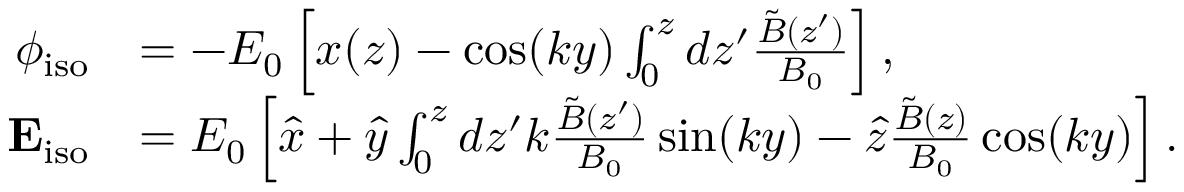Convert formula to latex. <formula><loc_0><loc_0><loc_500><loc_500>\begin{array} { r l } { \phi _ { i s o } } & { = - E _ { 0 } \left [ x ( z ) - \cos ( k y ) \int _ { 0 } ^ { z } d z ^ { \prime } \frac { \tilde { B } ( z ^ { \prime } ) } { B _ { 0 } } \right ] , } \\ { E _ { i s o } } & { = E _ { 0 } \left [ \hat { x } + \hat { y } \int _ { 0 } ^ { z } d z ^ { \prime } k \frac { \tilde { B } ( z ^ { \prime } ) } { B _ { 0 } } \sin ( k y ) - \hat { z } \frac { \tilde { B } ( z ) } { B _ { 0 } } \cos ( k y ) \right ] . } \end{array}</formula> 